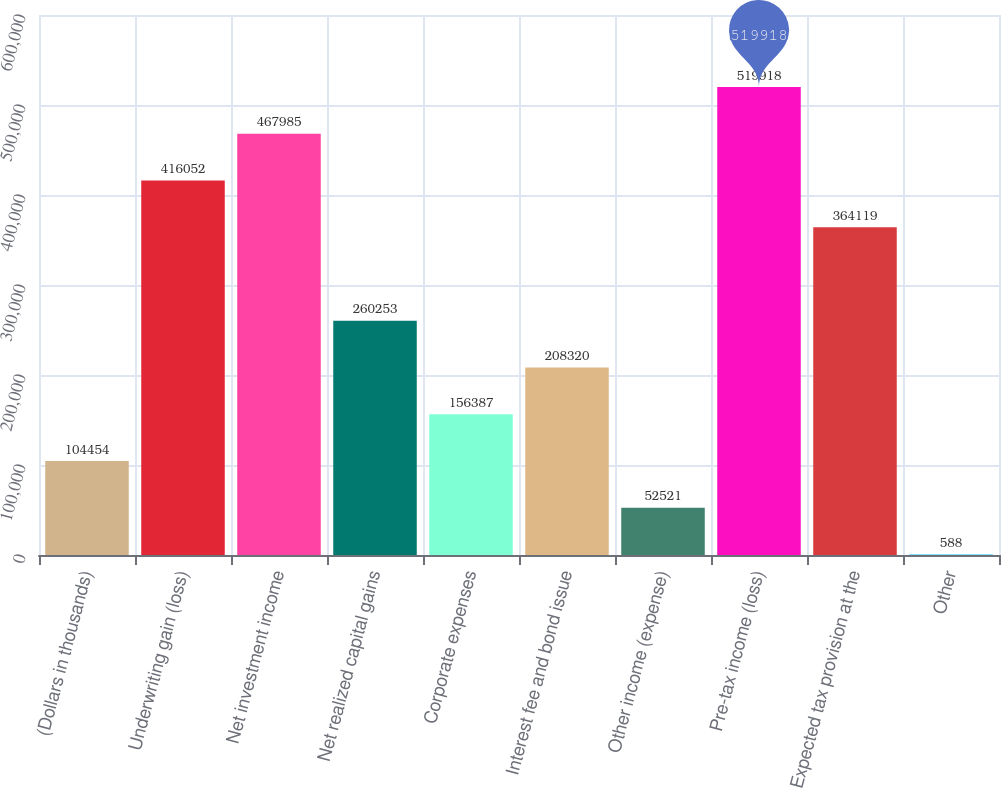Convert chart to OTSL. <chart><loc_0><loc_0><loc_500><loc_500><bar_chart><fcel>(Dollars in thousands)<fcel>Underwriting gain (loss)<fcel>Net investment income<fcel>Net realized capital gains<fcel>Corporate expenses<fcel>Interest fee and bond issue<fcel>Other income (expense)<fcel>Pre-tax income (loss)<fcel>Expected tax provision at the<fcel>Other<nl><fcel>104454<fcel>416052<fcel>467985<fcel>260253<fcel>156387<fcel>208320<fcel>52521<fcel>519918<fcel>364119<fcel>588<nl></chart> 